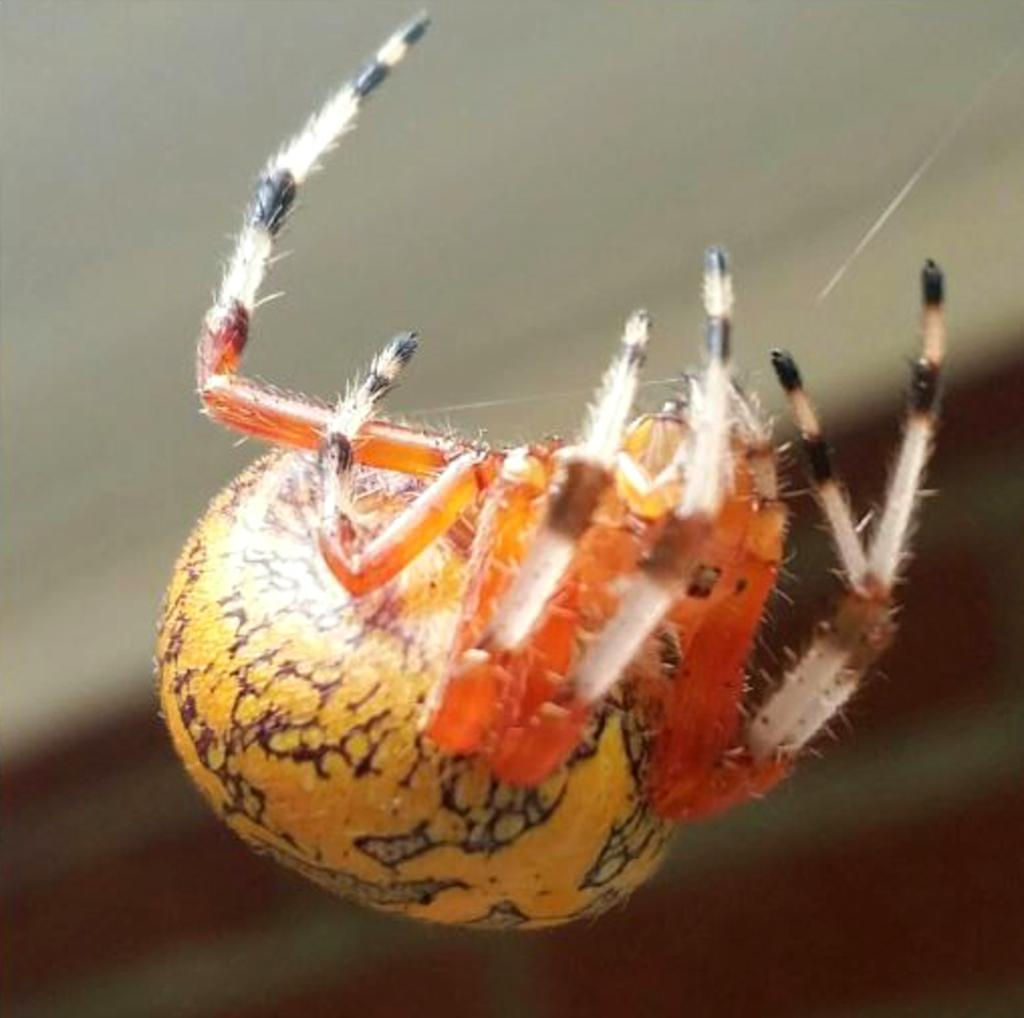What is the main subject of the image? The main subject of the image is a spider. What is the spider doing in the image? The spider has a web in the image. Can you describe the background of the image? The background of the image has a blurred view. What type of toys can be seen in the image? There are no toys present in the image; it features a spider with a web. Can you tell me how many screws are visible in the image? There are no screws visible in the image. 